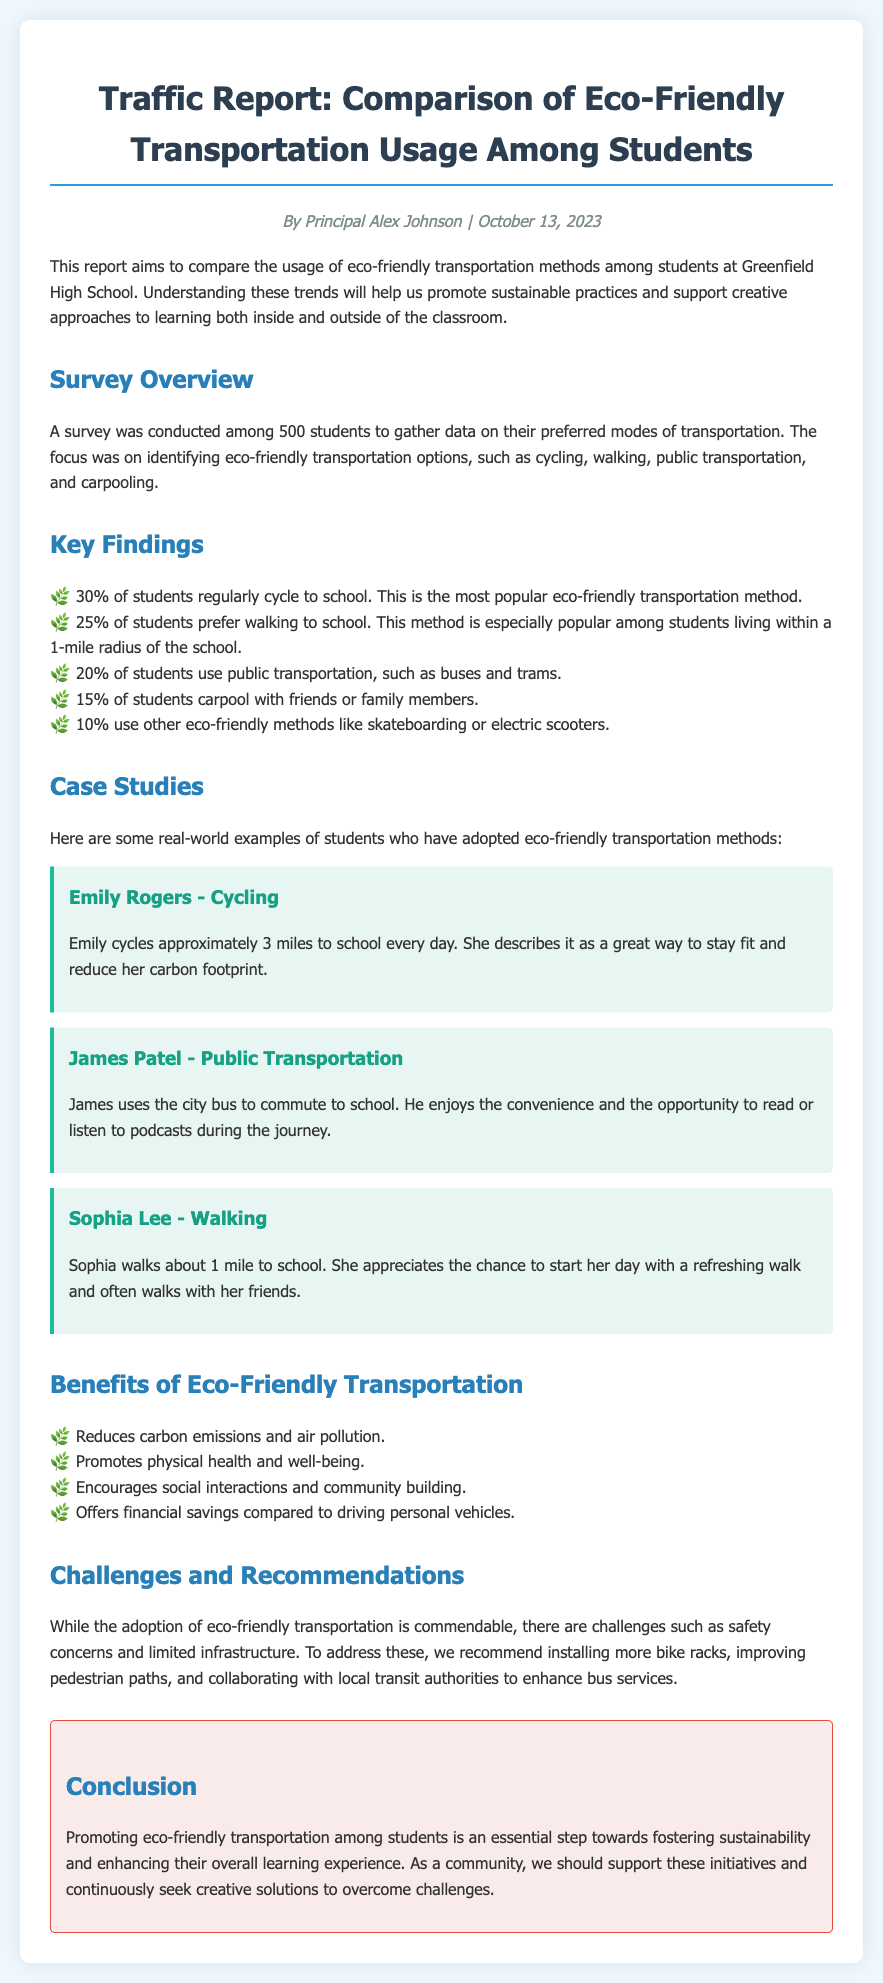What is the total number of students surveyed? The document states that a survey was conducted among 500 students.
Answer: 500 What percentage of students bike to school? The report indicates that 30% of students regularly cycle to school.
Answer: 30% Who is the author of the report? The author mentioned in the document is Principal Alex Johnson.
Answer: Principal Alex Johnson What eco-friendly transportation method is used by the least number of students? The document lists that 10% of students use other eco-friendly methods like skateboarding or electric scooters, which is the lowest percentage.
Answer: 10% What is one challenge mentioned in the report regarding eco-friendly transportation? The report discusses safety concerns as one of the challenges in adopting eco-friendly transportation.
Answer: Safety concerns Which eco-friendly method is popular among students living within a 1-mile radius? The report mentions that walking is especially popular among students living within a 1-mile radius of the school.
Answer: Walking What is one of the benefits of eco-friendly transportation listed in the document? The report highlights that eco-friendly transportation reduces carbon emissions and air pollution as a key benefit.
Answer: Reduces carbon emissions and air pollution How many case studies are presented in the report? The document presents three case studies of students who adopted eco-friendly transportation methods.
Answer: Three 